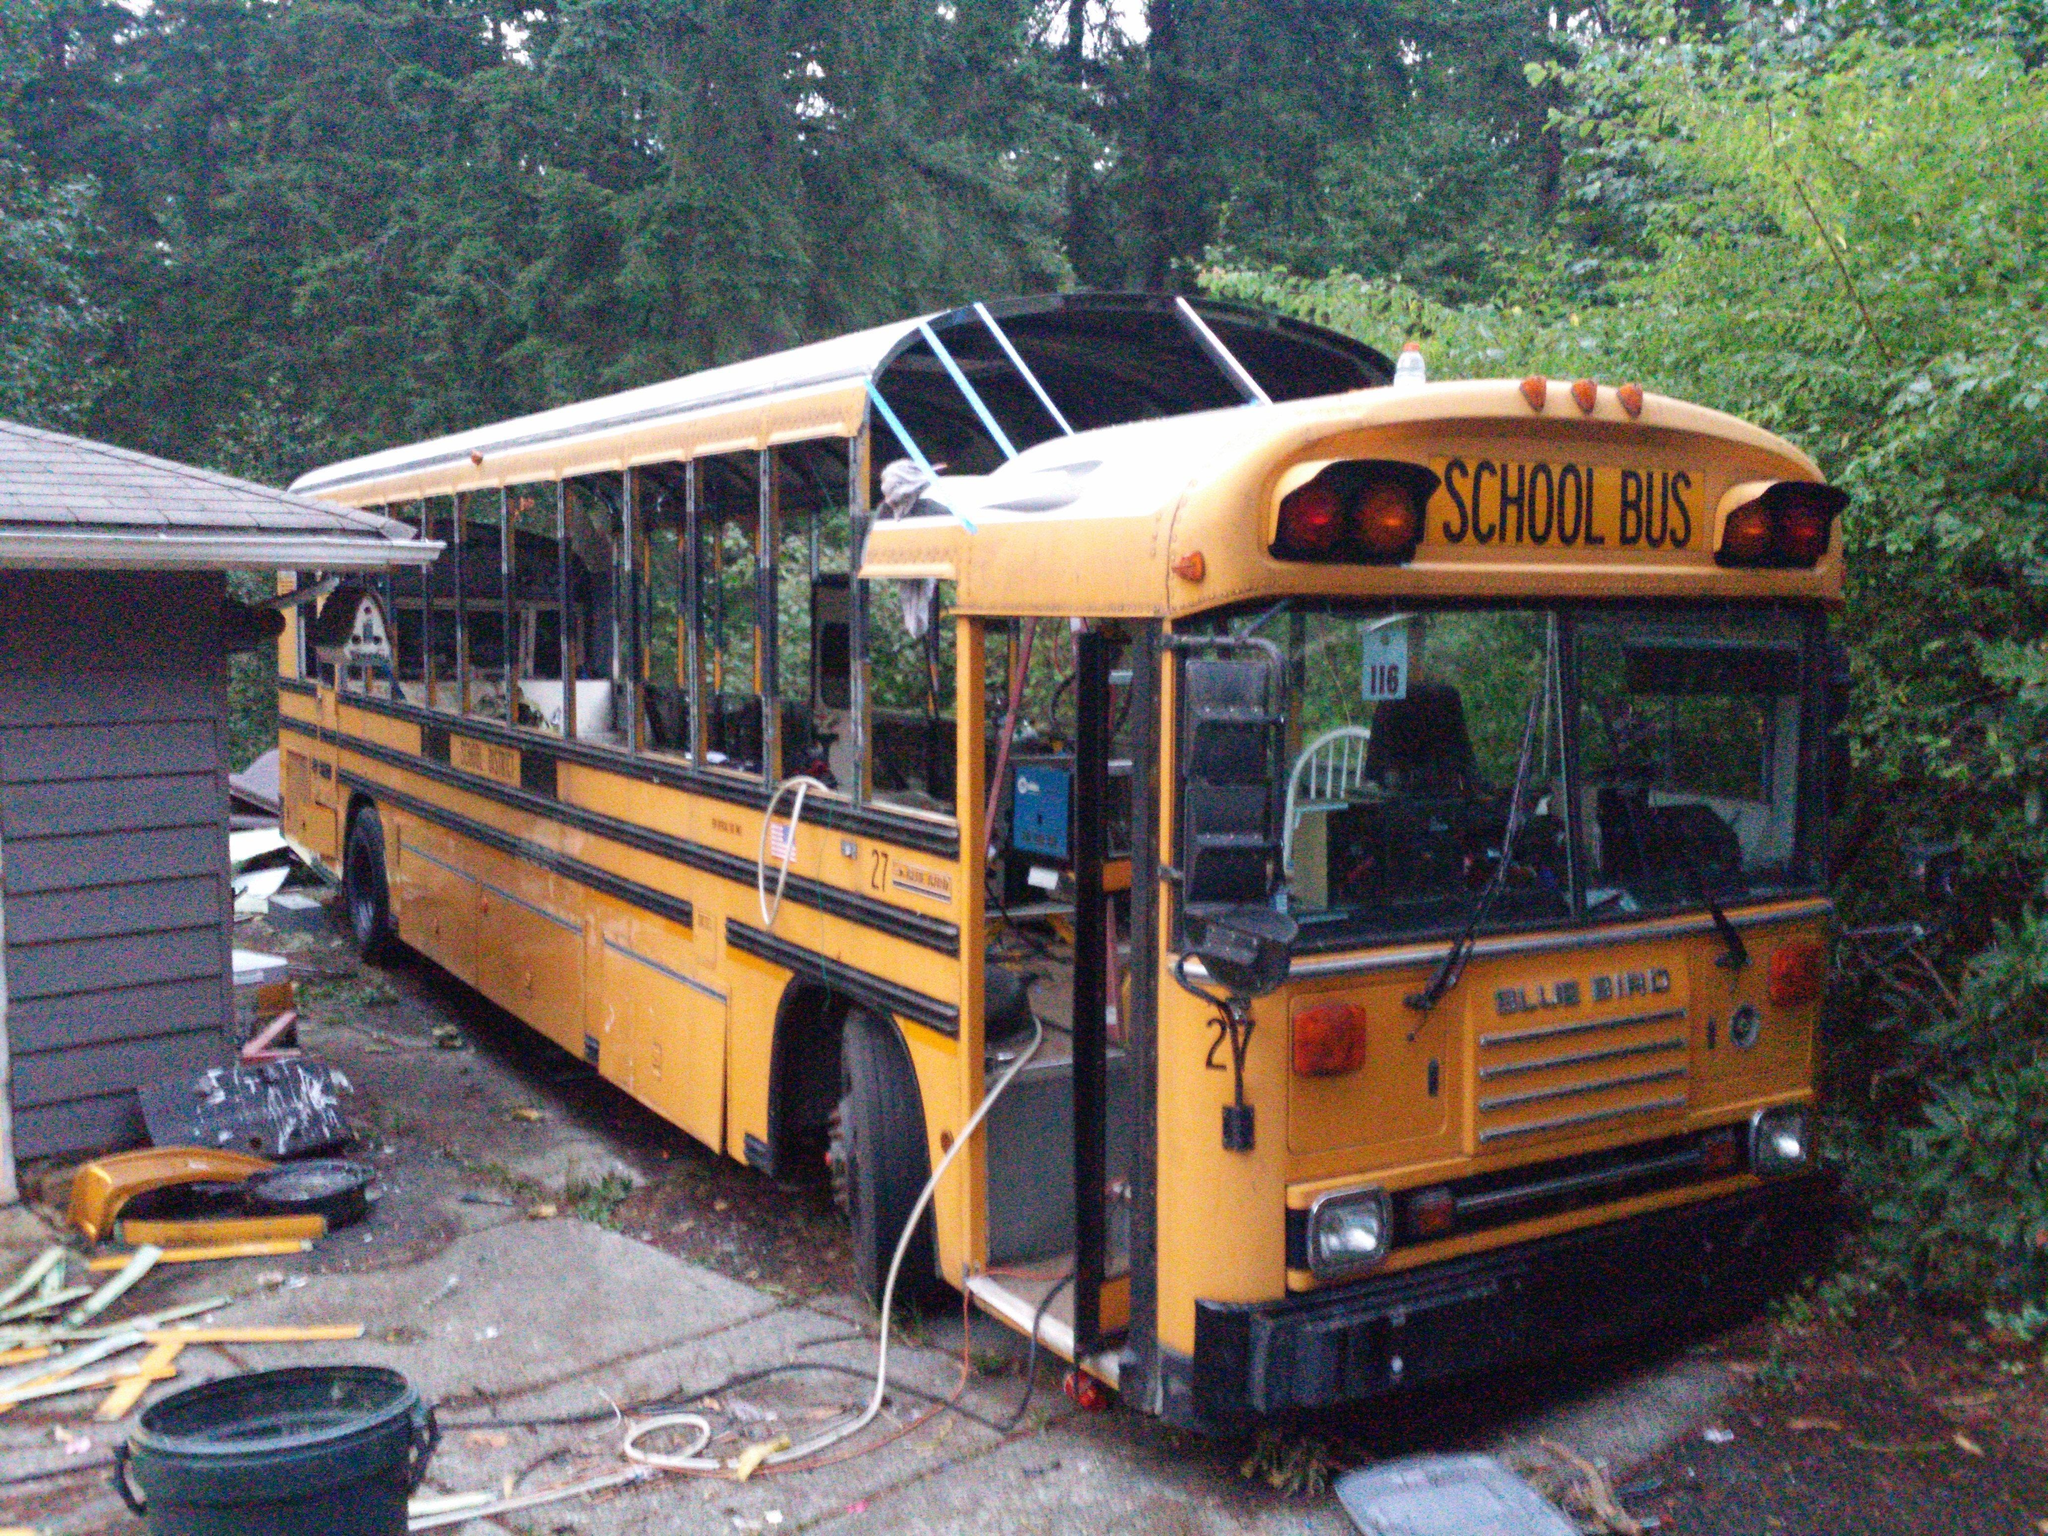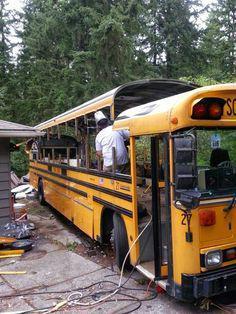The first image is the image on the left, the second image is the image on the right. Analyze the images presented: Is the assertion "The school buses in both pictures are facing left." valid? Answer yes or no. No. The first image is the image on the left, the second image is the image on the right. Evaluate the accuracy of this statement regarding the images: "One of the images features two school buses beside each other and the other image shows a single school bus.". Is it true? Answer yes or no. No. 